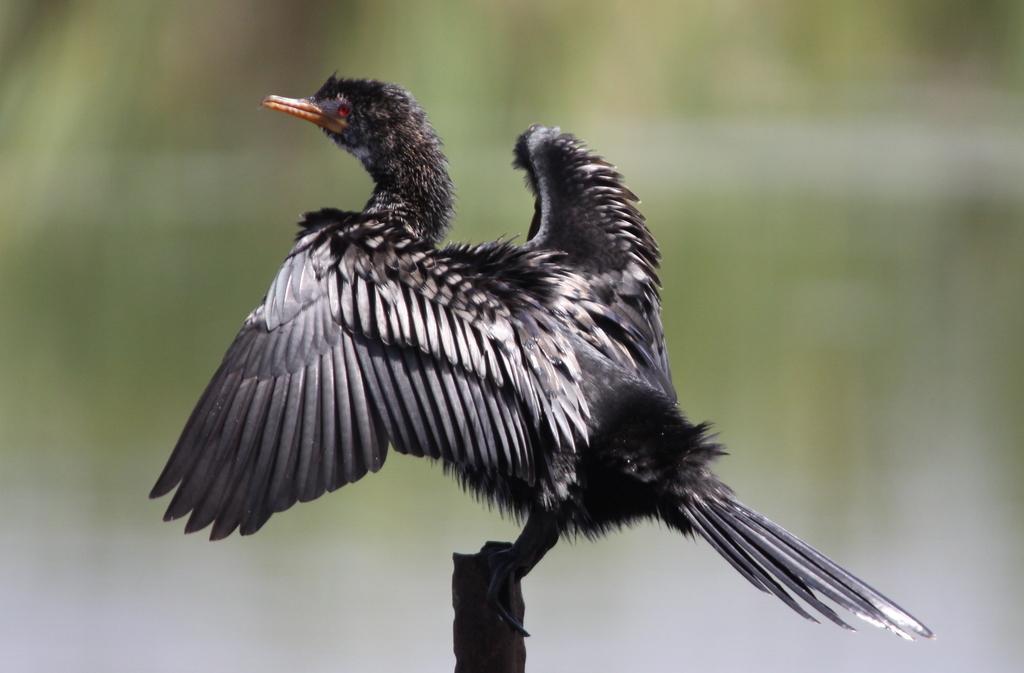Can you describe this image briefly? This picture contains a bird which is in black color. It has a beak in orange color. In the background, it is green in color and it is blurred. 